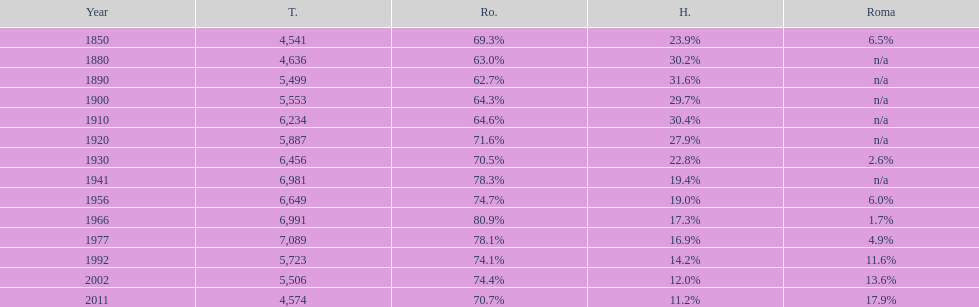What year had the next highest percentage for roma after 2011? 2002. 